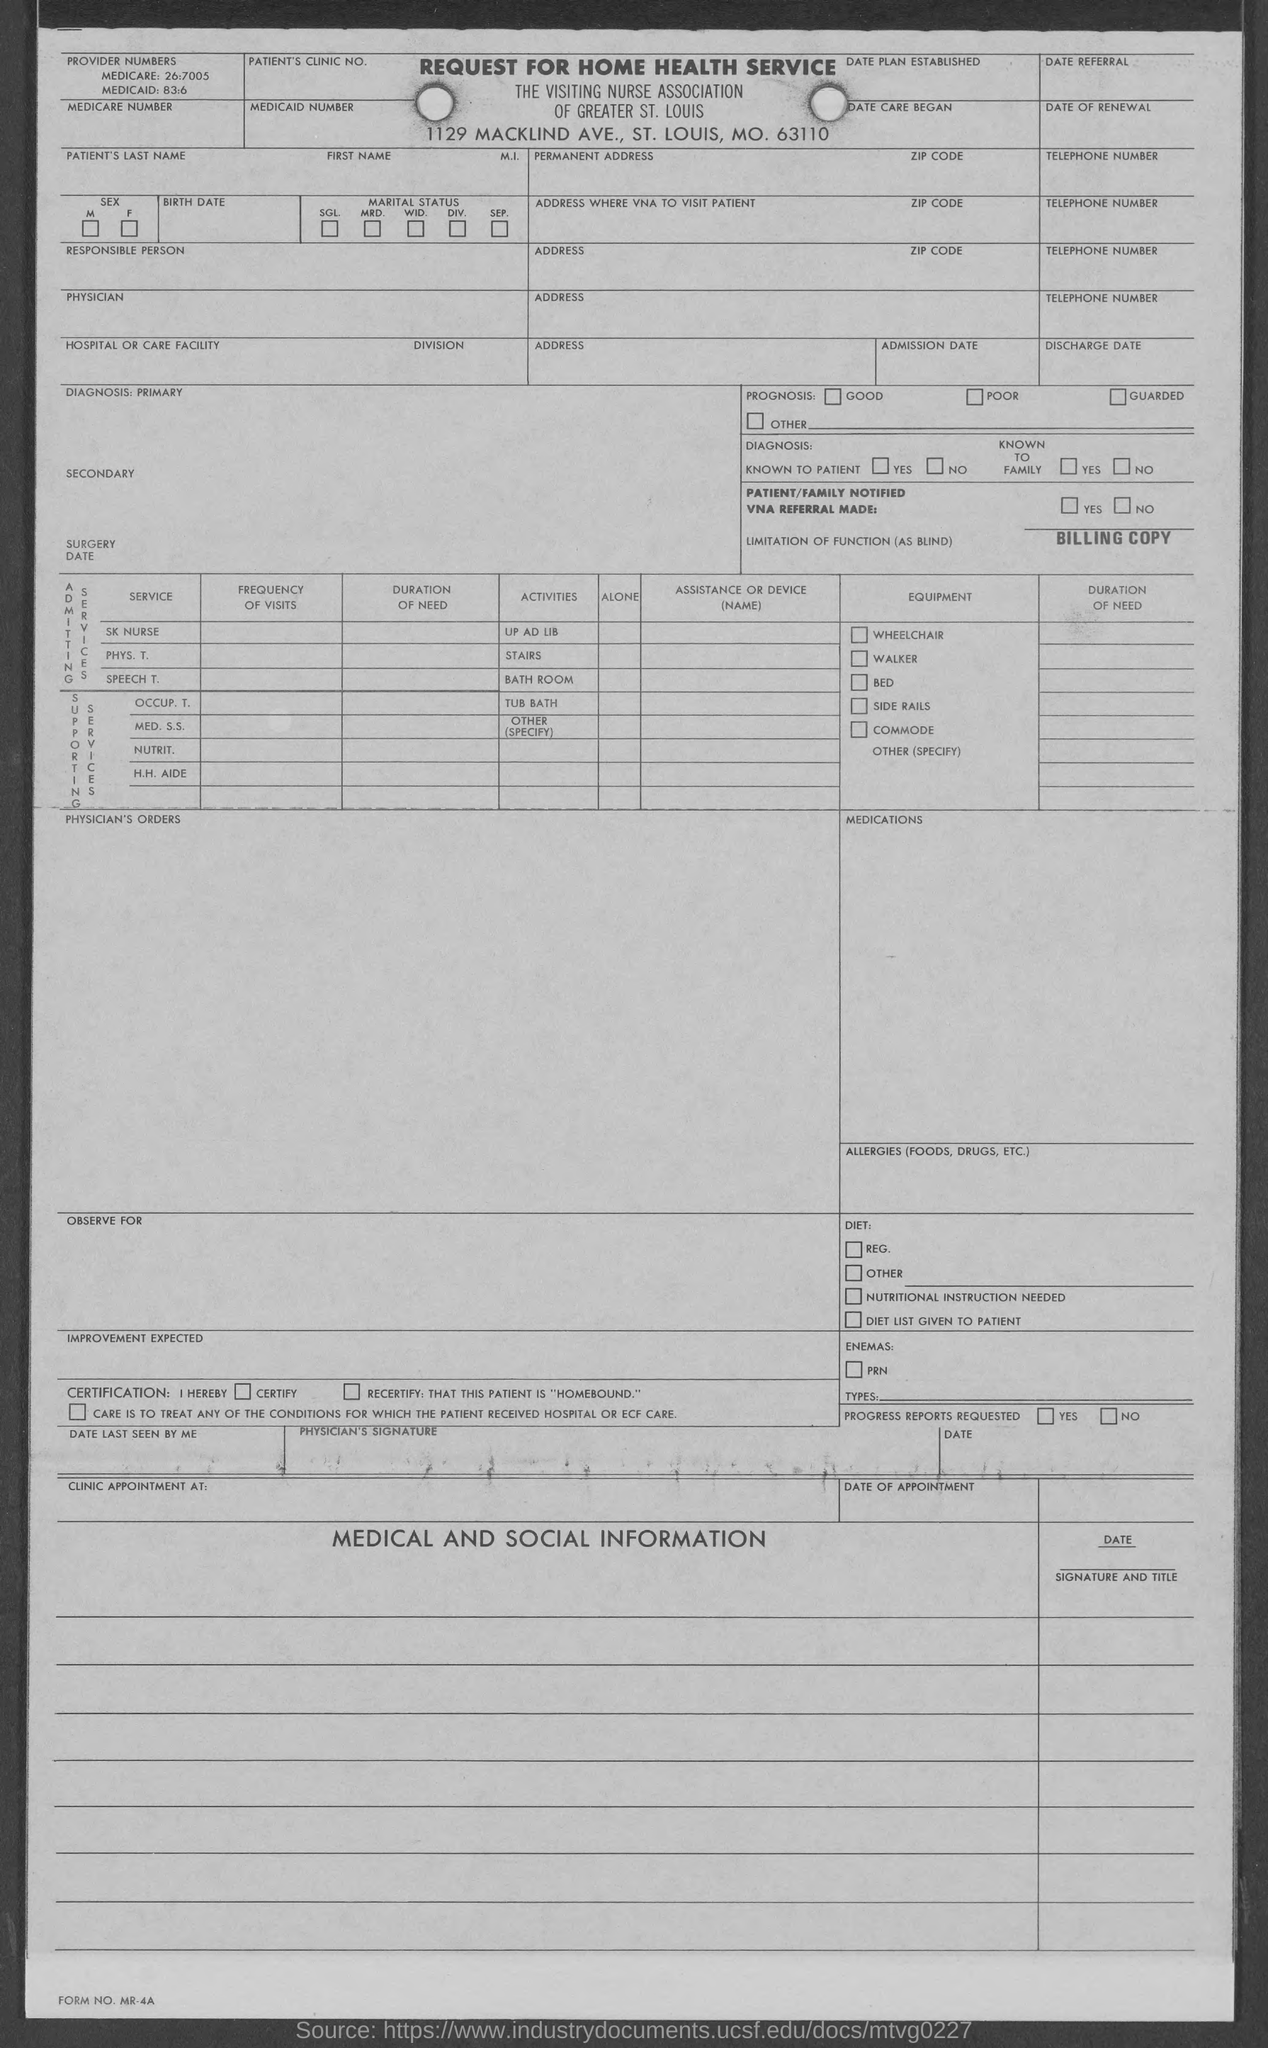Mention a couple of crucial points in this snapshot. The FORM NO. mentioned at the bottom left corner is MR-4A. The zip code provided in the form is 63110. The title of the form is REQUEST FOR HOME HEALTH SERVICE. 